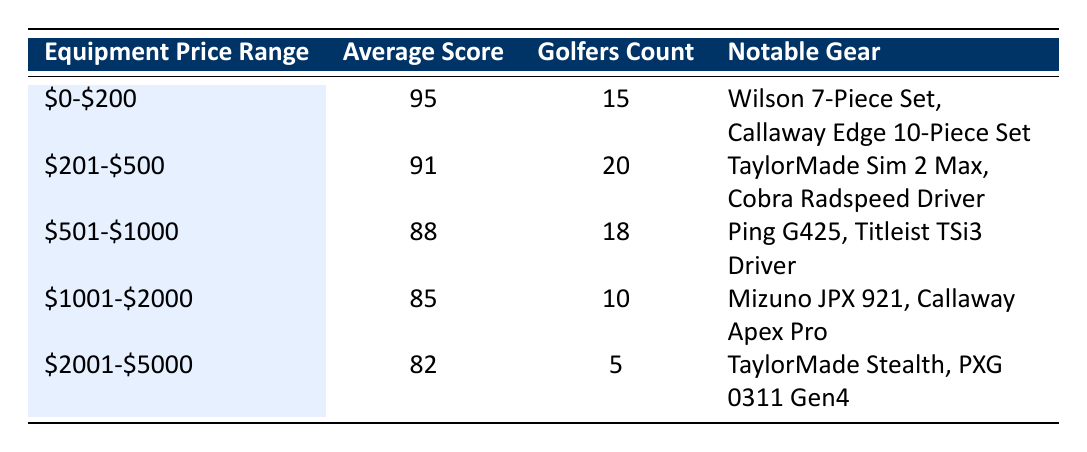What is the average score for golfers using equipment priced between $0 and $200? According to the table, the average score for golfers using equipment priced between $0 and $200 is directly listed as 95.
Answer: 95 How many golfers used equipment priced between $1001 and $2000? The table shows that there are 10 golfers using equipment priced within the range of $1001 to $2000.
Answer: 10 Is the average score for golfers using equipment priced between $501 and $1000 higher than those using gear priced between $2001 and $5000? From the table, the average score for the $501 to $1000 range is 88, while for the $2001 to $5000 range it is 82. Since 88 is greater than 82, the statement is true.
Answer: Yes What is the total number of golfers across all equipment price ranges listed in the table? To find the total number of golfers, we need to sum the golfers count for each price range: 15 + 20 + 18 + 10 + 5 = 68.
Answer: 68 Which price range has the highest notable gear listed? By examining the table, the $0 to $200 price range has two notable gears listed (Wilson 7-Piece Set, Callaway Edge 10-Piece Set), while the other price ranges do not exceed this number. Therefore, this price range has the highest notable gear.
Answer: $0-$200 What is the difference in average scores between the $201-$500 and $1001-$2000 price ranges? The average score for the $201-$500 range is 91, and for the $1001-$2000 range, it is 85. The difference is calculated as 91 - 85 = 6.
Answer: 6 Is it true that golfers using equipment in the $2001-$5000 range have a higher average score than those using the $501-$1000 range? Looking at the table, the average score for the $2001-$5000 range is 82, which is lower than the $501-$1000 range’s average score of 88. Therefore, the statement is false.
Answer: No What are the average score trends as the equipment price increases from $0-$200 to $2001-$5000? Observing the table, the average scores trend downward as the equipment price increases: 95, 91, 88, 85, and finally 82. This indicates a consistent decline in average scores with higher price ranges.
Answer: Declining trend 